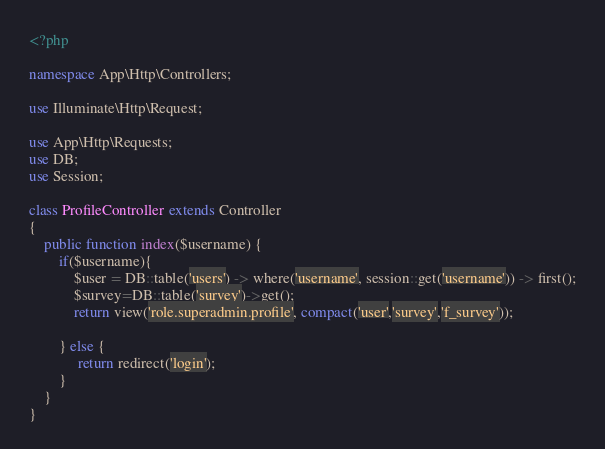Convert code to text. <code><loc_0><loc_0><loc_500><loc_500><_PHP_><?php

namespace App\Http\Controllers;

use Illuminate\Http\Request;

use App\Http\Requests;
use DB;
use Session;

class ProfileController extends Controller
{
	public function index($username) {
	    if($username){
		    $user = DB::table('users') -> where('username', session::get('username')) -> first();
		    $survey=DB::table('survey')->get(); 
		    return view('role.superadmin.profile', compact('user','survey','f_survey')); 
	            
	    } else { 
	         return redirect('login');
	    }
	}
}
</code> 